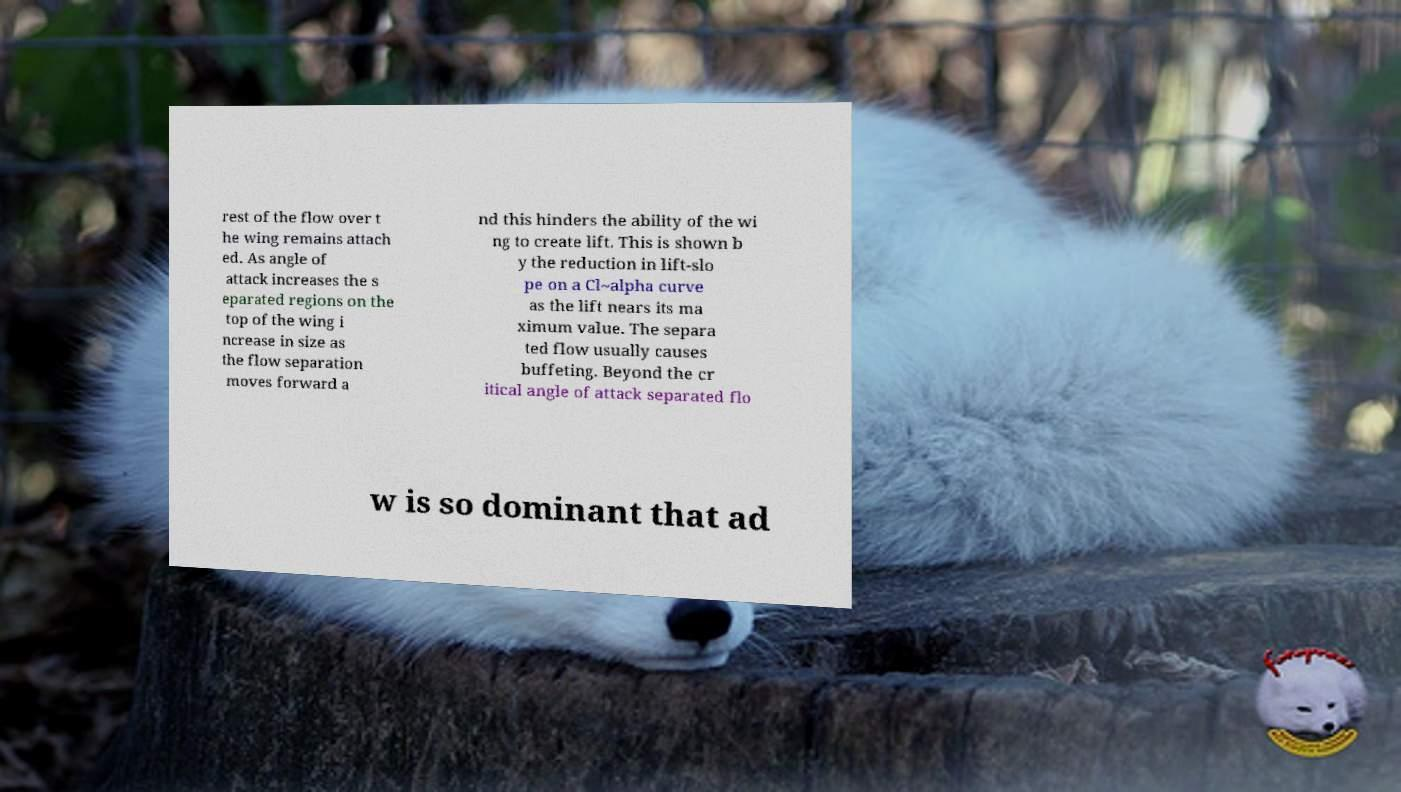Could you extract and type out the text from this image? rest of the flow over t he wing remains attach ed. As angle of attack increases the s eparated regions on the top of the wing i ncrease in size as the flow separation moves forward a nd this hinders the ability of the wi ng to create lift. This is shown b y the reduction in lift-slo pe on a Cl~alpha curve as the lift nears its ma ximum value. The separa ted flow usually causes buffeting. Beyond the cr itical angle of attack separated flo w is so dominant that ad 